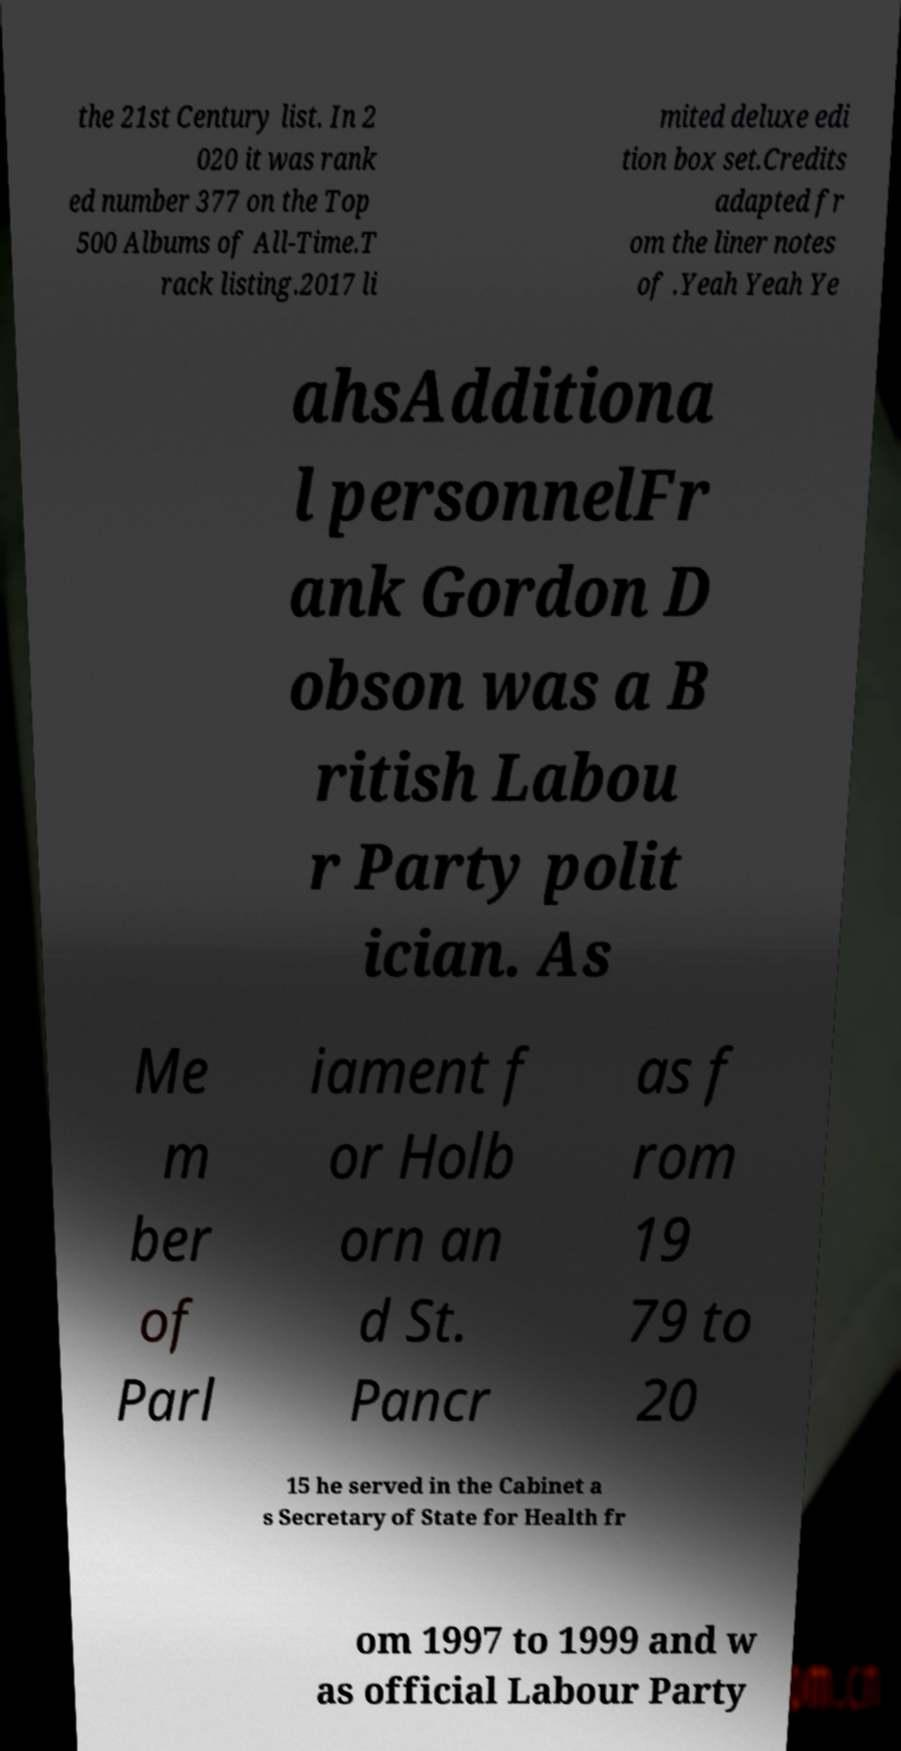For documentation purposes, I need the text within this image transcribed. Could you provide that? the 21st Century list. In 2 020 it was rank ed number 377 on the Top 500 Albums of All-Time.T rack listing.2017 li mited deluxe edi tion box set.Credits adapted fr om the liner notes of .Yeah Yeah Ye ahsAdditiona l personnelFr ank Gordon D obson was a B ritish Labou r Party polit ician. As Me m ber of Parl iament f or Holb orn an d St. Pancr as f rom 19 79 to 20 15 he served in the Cabinet a s Secretary of State for Health fr om 1997 to 1999 and w as official Labour Party 